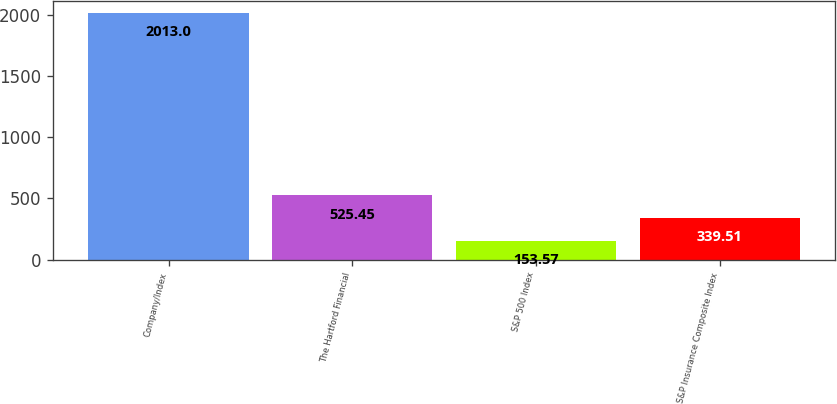<chart> <loc_0><loc_0><loc_500><loc_500><bar_chart><fcel>Company/Index<fcel>The Hartford Financial<fcel>S&P 500 Index<fcel>S&P Insurance Composite Index<nl><fcel>2013<fcel>525.45<fcel>153.57<fcel>339.51<nl></chart> 